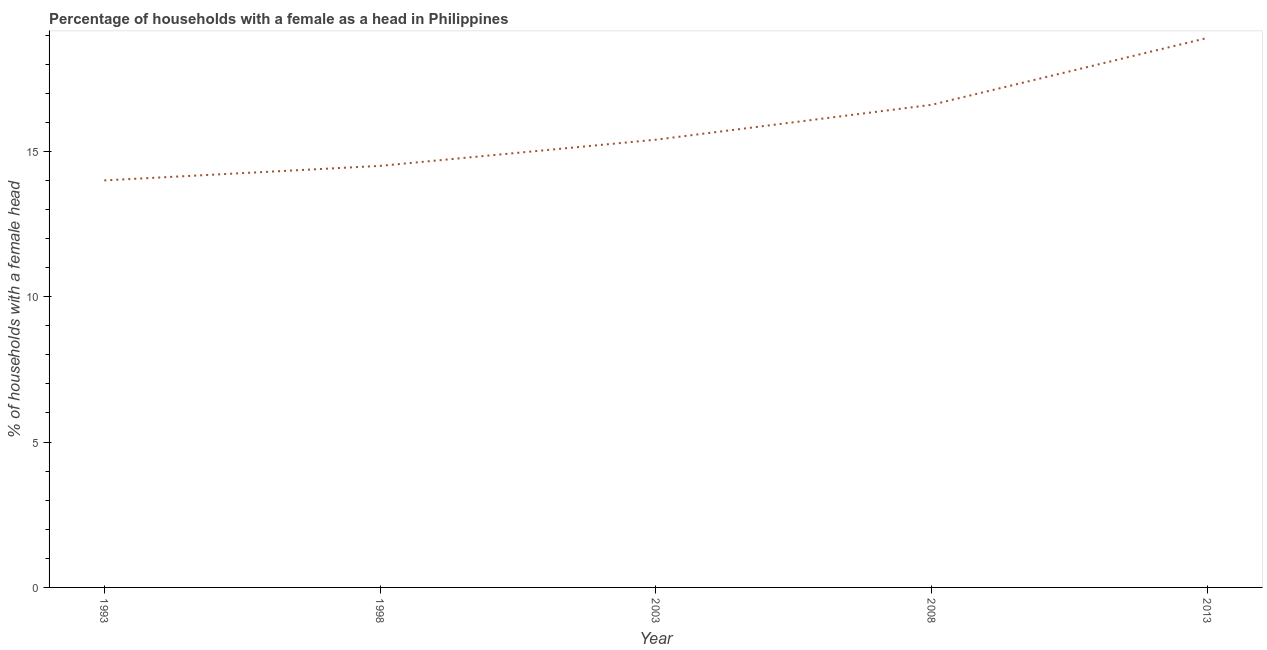Across all years, what is the maximum number of female supervised households?
Your answer should be compact. 18.9. In which year was the number of female supervised households maximum?
Ensure brevity in your answer.  2013. What is the sum of the number of female supervised households?
Ensure brevity in your answer.  79.4. What is the difference between the number of female supervised households in 1993 and 2008?
Your answer should be very brief. -2.6. What is the average number of female supervised households per year?
Make the answer very short. 15.88. What is the median number of female supervised households?
Provide a succinct answer. 15.4. In how many years, is the number of female supervised households greater than 10 %?
Provide a succinct answer. 5. Do a majority of the years between 2003 and 2008 (inclusive) have number of female supervised households greater than 12 %?
Ensure brevity in your answer.  Yes. What is the ratio of the number of female supervised households in 1993 to that in 2008?
Offer a terse response. 0.84. Is the number of female supervised households in 1993 less than that in 2013?
Provide a short and direct response. Yes. Is the difference between the number of female supervised households in 2008 and 2013 greater than the difference between any two years?
Keep it short and to the point. No. What is the difference between the highest and the second highest number of female supervised households?
Provide a succinct answer. 2.3. What is the difference between the highest and the lowest number of female supervised households?
Offer a very short reply. 4.9. In how many years, is the number of female supervised households greater than the average number of female supervised households taken over all years?
Your response must be concise. 2. How many lines are there?
Keep it short and to the point. 1. How many years are there in the graph?
Provide a short and direct response. 5. Are the values on the major ticks of Y-axis written in scientific E-notation?
Ensure brevity in your answer.  No. What is the title of the graph?
Offer a very short reply. Percentage of households with a female as a head in Philippines. What is the label or title of the Y-axis?
Provide a succinct answer. % of households with a female head. What is the % of households with a female head in 2003?
Your response must be concise. 15.4. What is the % of households with a female head in 2013?
Make the answer very short. 18.9. What is the difference between the % of households with a female head in 1993 and 2003?
Your answer should be very brief. -1.4. What is the difference between the % of households with a female head in 1993 and 2008?
Ensure brevity in your answer.  -2.6. What is the difference between the % of households with a female head in 1993 and 2013?
Provide a succinct answer. -4.9. What is the difference between the % of households with a female head in 1998 and 2003?
Offer a terse response. -0.9. What is the difference between the % of households with a female head in 1998 and 2013?
Keep it short and to the point. -4.4. What is the difference between the % of households with a female head in 2003 and 2008?
Offer a very short reply. -1.2. What is the difference between the % of households with a female head in 2003 and 2013?
Your answer should be very brief. -3.5. What is the difference between the % of households with a female head in 2008 and 2013?
Your response must be concise. -2.3. What is the ratio of the % of households with a female head in 1993 to that in 1998?
Your answer should be very brief. 0.97. What is the ratio of the % of households with a female head in 1993 to that in 2003?
Your answer should be compact. 0.91. What is the ratio of the % of households with a female head in 1993 to that in 2008?
Provide a succinct answer. 0.84. What is the ratio of the % of households with a female head in 1993 to that in 2013?
Your answer should be compact. 0.74. What is the ratio of the % of households with a female head in 1998 to that in 2003?
Offer a very short reply. 0.94. What is the ratio of the % of households with a female head in 1998 to that in 2008?
Your answer should be compact. 0.87. What is the ratio of the % of households with a female head in 1998 to that in 2013?
Provide a short and direct response. 0.77. What is the ratio of the % of households with a female head in 2003 to that in 2008?
Offer a terse response. 0.93. What is the ratio of the % of households with a female head in 2003 to that in 2013?
Provide a succinct answer. 0.81. What is the ratio of the % of households with a female head in 2008 to that in 2013?
Ensure brevity in your answer.  0.88. 